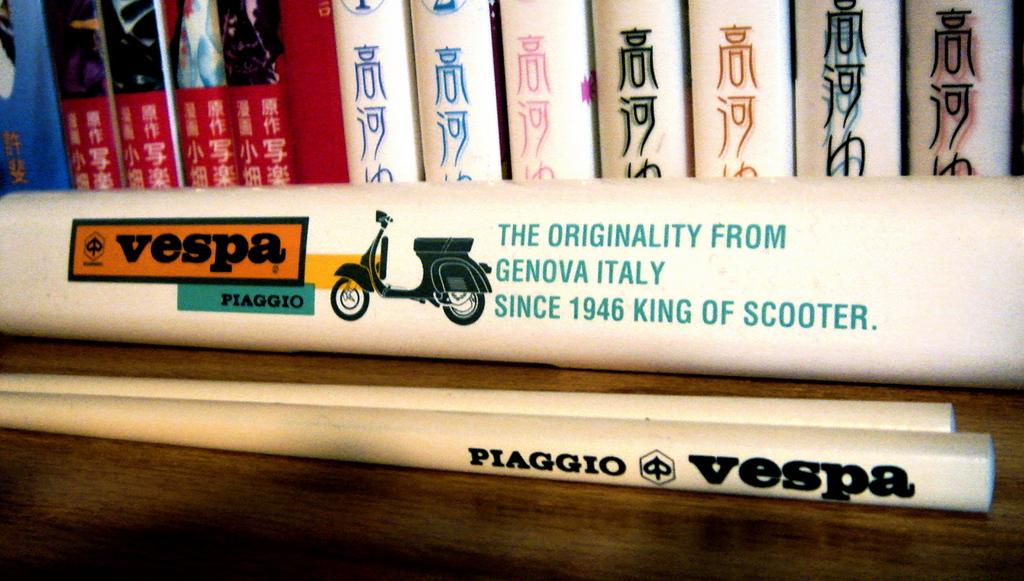Provide a one-sentence caption for the provided image. books lined up near a Vespa Piaggio sign. 